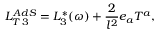Convert formula to latex. <formula><loc_0><loc_0><loc_500><loc_500>L _ { T \, 3 } ^ { A d S } = L _ { 3 } ^ { * } ( \omega ) + \frac { 2 } { l ^ { 2 } } e _ { a } T ^ { a } ,</formula> 